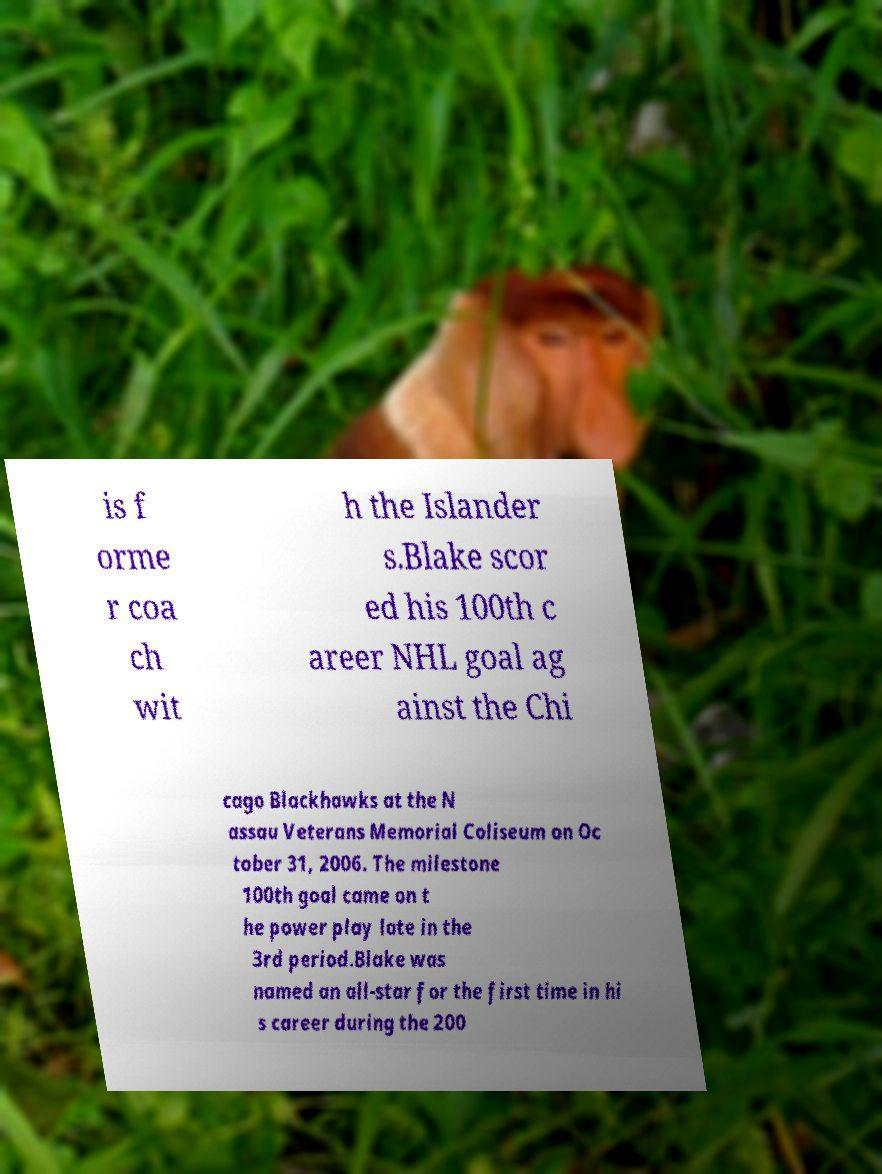Please read and relay the text visible in this image. What does it say? is f orme r coa ch wit h the Islander s.Blake scor ed his 100th c areer NHL goal ag ainst the Chi cago Blackhawks at the N assau Veterans Memorial Coliseum on Oc tober 31, 2006. The milestone 100th goal came on t he power play late in the 3rd period.Blake was named an all-star for the first time in hi s career during the 200 